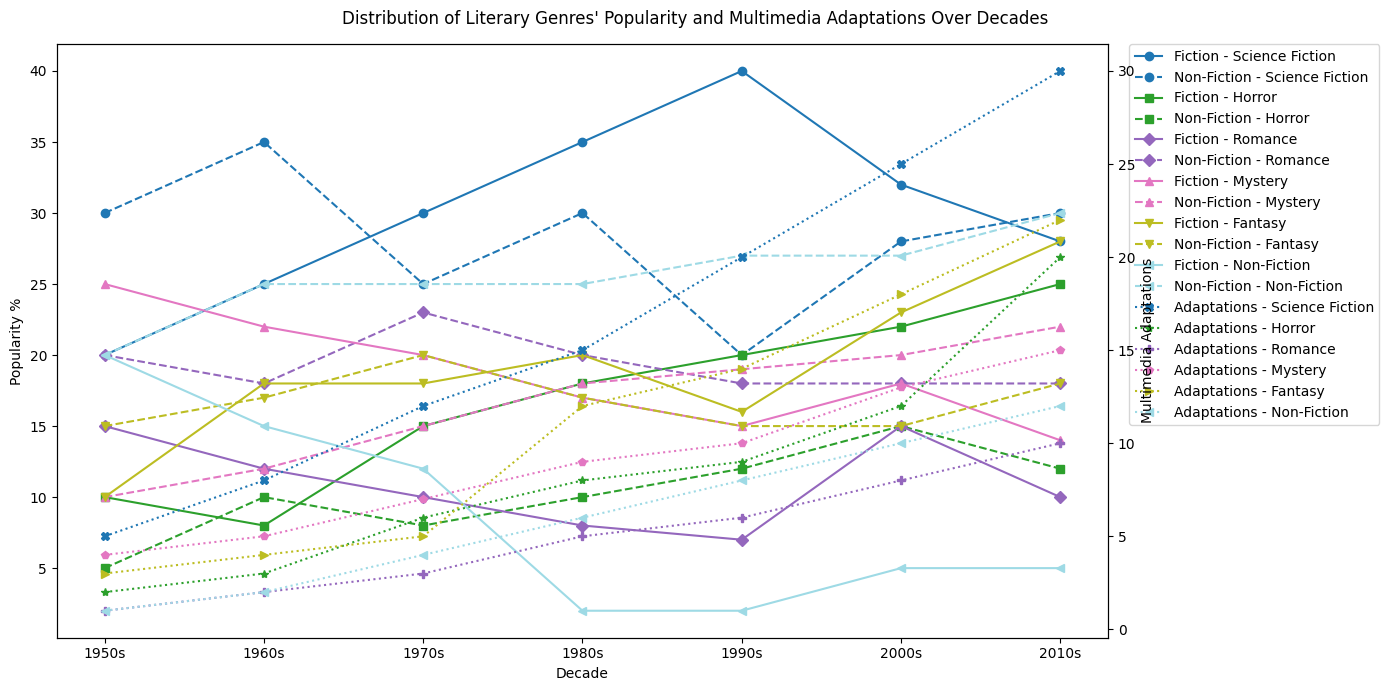How has the popularity of Science Fiction in fiction changed from the 1950s to the 2010s? To determine this, look at the fiction popularity % of Science Fiction in the 1950s and then in the 2010s. In the 1950s, it is 20%, and in the 2010s, it is 28%. The popularity has increased from 20% to 28% over this period.
Answer: Increased from 20% to 28% Which genre had the most multimedia adaptations in the 2010s? To answer this, you need to compare the values of multimedia adaptations for all genres in the 2010s. Science Fiction had 30, Horror had 20, Romance had 10, Mystery had 15, Fantasy had 22, and Non-Fiction had 12. Science Fiction had the most with 30 adaptations.
Answer: Science Fiction Did the popularity of Non-Fiction in non-fiction literature increase or decrease from the 1950s to the 2010s? Compare the non-fiction popularity % for Non-Fiction in the 1950s and the 2010s. In the 1950s, it is 20% and in the 2010s, it is 30%. The popularity increased from 20% to 30%.
Answer: Increased from 20% to 30% What is the sum of multimedia adaptations for Fantasy in the 1980s and 2010s? To find the sum, add the multimedia adaptations of Fantasy in the 1980s, which is 12, with those in the 2010s, which is 22. 12 + 22 = 34.
Answer: 34 Between Horror and Romance, which genre saw a greater increase in fiction popularity % between the 1950s and the 1990s? Compare the difference in fiction popularity % from the 1950s to the 1990s for both Horror and Romance. Horror increased from 10% to 20%, a 10% increase. Romance decreased from 15% to 7%, a 8% decrease. Horror had a greater increase.
Answer: Horror How did the number of multimedia adaptations for Mystery evolve from the 1950s to the 2010s? List the number of multimedia adaptations for Mystery across the decades: 1950s (4), 1960s (5), 1970s (7), 1980s (9), 1990s (10), 2000s (13), 2010s (15). The number steadily increased.
Answer: Steadily increased Compare the non-fiction popularity % of Romance and Fantasy in the 2000s. Look at the non-fiction popularity % for Romance and Fantasy in the 2000s. Romance has 18% and Fantasy has 15%. Romance is more popular in non-fiction.
Answer: Romance What trend do you observe in the fiction popularity % of Science Fiction from the 1950s to the 1990s? List the fiction popularity % for Science Fiction across these decades: 1950s (20), 1960s (25), 1970s (30), 1980s (35), 1990s (40). The fiction popularity % increases in each decade.
Answer: Increasing trend Which genre had a consistent increase in both fiction and non-fiction popularity % and also an increase in multimedia adaptations from the 1950s to the 2010s? Compare all three attributes (fiction and non-fiction popularity %, and multimedia adaptations) across all genres from the 1950s to the 2010s. Science Fiction had increased fiction popularity % (20% to 28%), increased non-fiction popularity % (30% to 30%), and increased multimedia adaptations (5 to 30), making it the genre with consistent increases.
Answer: Science Fiction 